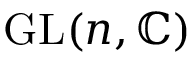<formula> <loc_0><loc_0><loc_500><loc_500>{ G L } ( n , \mathbb { C } )</formula> 